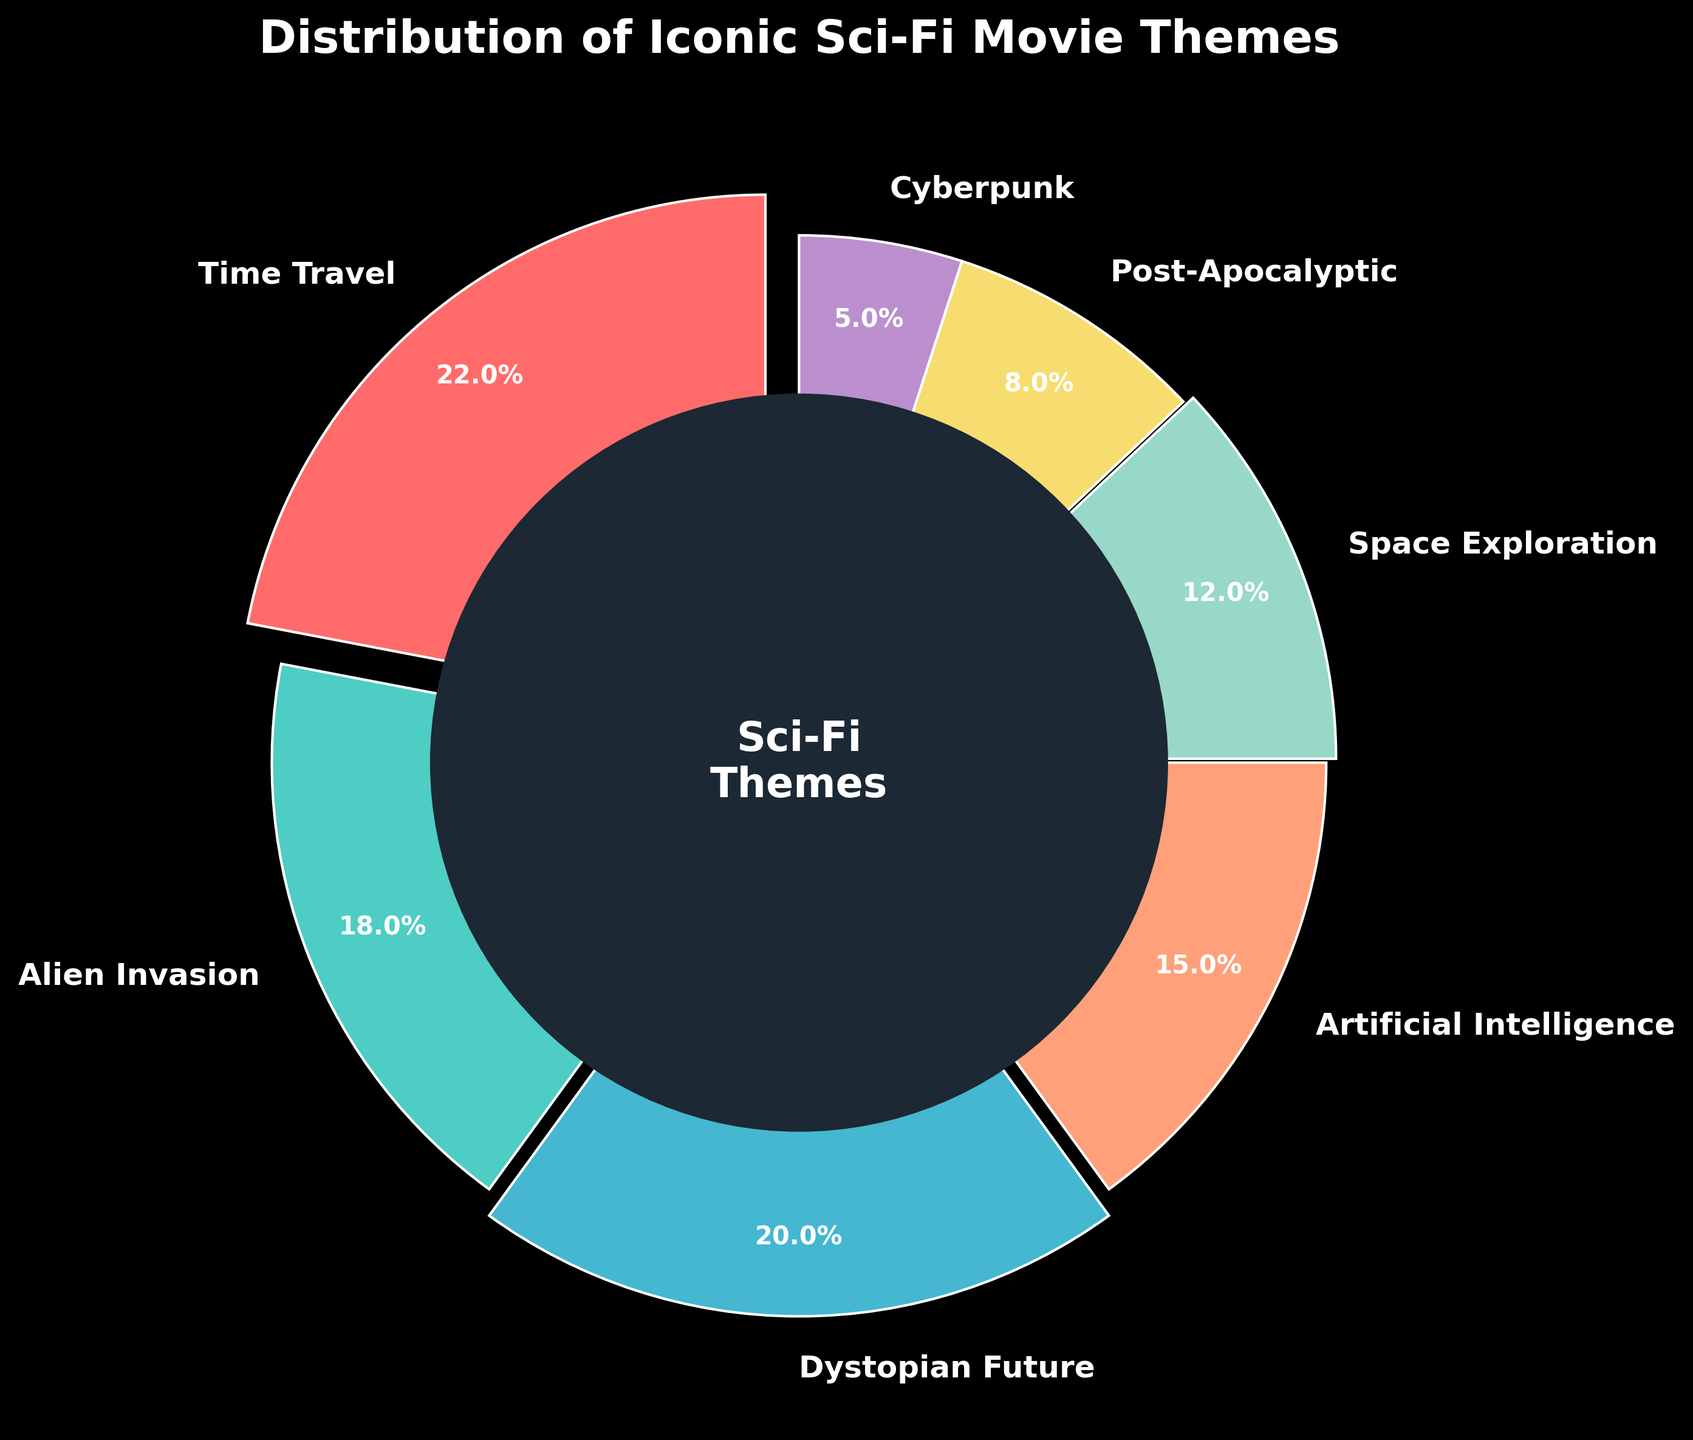What theme has the highest percentage? The pie chart visual shows various sci-fi themes with their respective percentages. Time Travel has the largest slice, which represents 22%.
Answer: Time Travel What is the combined percentage of Alien Invasion and Space Exploration themes? According to the pie chart, Alien Invasion accounts for 18% and Space Exploration for 12%. Adding these two percentages together, we get 18% + 12% = 30%.
Answer: 30% Which theme occupies the smallest portion of the pie chart? By looking at the pie chart, Cyberpunk is the smallest slice. Its label indicates that it represents 5% of the total.
Answer: Cyberpunk How much larger is the portion of Time Travel compared to Cyberpunk? From the pie chart, Time Travel is 22% and Cyberpunk is 5%. The difference between these two is 22% - 5% = 17%.
Answer: 17% Which three themes together contribute to exactly half of the total percentage? From the pie chart, selecting the themes with the closest cumulative percentages: Time Travel (22%), Alien Invasion (18%), and Post-Apocalyptic (8%) yield 22% + 18% + 8% = 48%. This is very close to half, though a bit under. However, choosing exactly half could be an iteration process because percentages given are discrete, but those three combined are closest to 50%.
Answer: Time Travel, Alien Invasion, Post-Apocalyptic What is the average percentage of the Post-Apocalyptic, Space Exploration, and Cyberpunk themes? The percentages are Post-Apocalyptic (8%), Space Exploration (12%), and Cyberpunk (5%). The sum is 8% + 12% + 5% = 25%, and the average is 25% / 3 ≈ 8.33%.
Answer: 8.33% Which is more common, Dystopian Future or Artificial Intelligence, and by how much? The chart shows Dystopian Future at 20% and Artificial Intelligence at 15%. The difference is 20% - 15% = 5%.
Answer: Dystopian Future by 5% What is the combined percentage for the least common two themes? The least common themes are Cyberpunk (5%) and Post-Apocalyptic (8%). Adding them together, we get 5% + 8% = 13%.
Answer: 13% What are the colors representing Alien Invasion and Cyberpunk themes? The pie chart uses distinct colors for each theme. Alien Invasion is shown in a teal color, and Cyberpunk is shown in a purple color.
Answer: Teal (Alien Invasion) and Purple (Cyberpunk) Which theme has a larger segment than Artificial Intelligence but smaller than Dystopian Future? The percentages are given as Artificial Intelligence (15%) and Dystopian Future (20%). The theme between these values is Alien Invasion with 18%.
Answer: Alien Invasion 